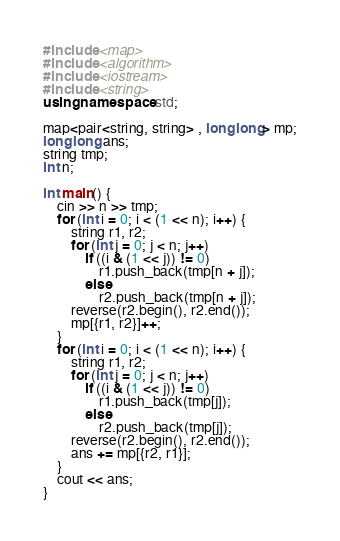Convert code to text. <code><loc_0><loc_0><loc_500><loc_500><_C++_>#include <map>
#include <algorithm>
#include <iostream>
#include <string>
using namespace std;

map<pair<string, string> , long long> mp;
long long ans;
string tmp;
int n;

int main() {
	cin >> n >> tmp;
	for (int i = 0; i < (1 << n); i++) {
		string r1, r2;
		for (int j = 0; j < n; j++)
			if ((i & (1 << j)) != 0)
				r1.push_back(tmp[n + j]);
			else
				r2.push_back(tmp[n + j]);
		reverse(r2.begin(), r2.end());
		mp[{r1, r2}]++;
	}
	for (int i = 0; i < (1 << n); i++) {
		string r1, r2;
		for (int j = 0; j < n; j++)
			if ((i & (1 << j)) != 0)
				r1.push_back(tmp[j]);
			else
				r2.push_back(tmp[j]);
		reverse(r2.begin(), r2.end());
		ans += mp[{r2, r1}];
	}
	cout << ans;
}</code> 